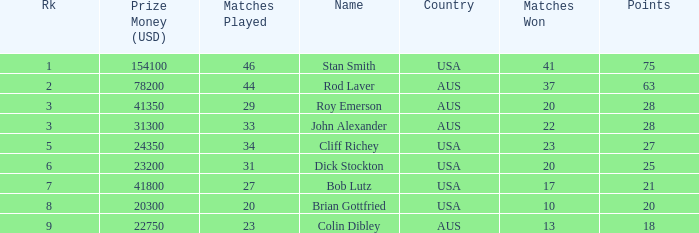Could you parse the entire table as a dict? {'header': ['Rk', 'Prize Money (USD)', 'Matches Played', 'Name', 'Country', 'Matches Won', 'Points'], 'rows': [['1', '154100', '46', 'Stan Smith', 'USA', '41', '75'], ['2', '78200', '44', 'Rod Laver', 'AUS', '37', '63'], ['3', '41350', '29', 'Roy Emerson', 'AUS', '20', '28'], ['3', '31300', '33', 'John Alexander', 'AUS', '22', '28'], ['5', '24350', '34', 'Cliff Richey', 'USA', '23', '27'], ['6', '23200', '31', 'Dick Stockton', 'USA', '20', '25'], ['7', '41800', '27', 'Bob Lutz', 'USA', '17', '21'], ['8', '20300', '20', 'Brian Gottfried', 'USA', '10', '20'], ['9', '22750', '23', 'Colin Dibley', 'AUS', '13', '18']]} How much prize money (in usd) did bob lutz win 41800.0. 